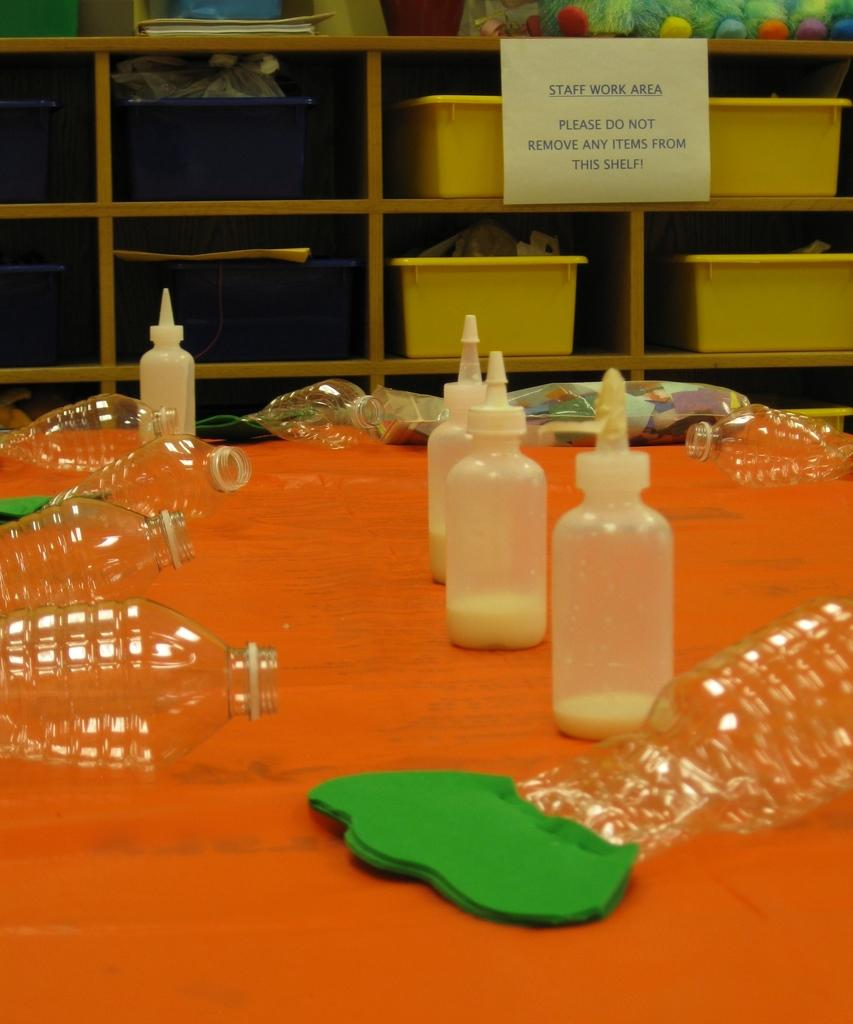What type of objects can be seen in the background of the image? There are containers in the background of the image. How are the containers arranged? The containers are in racks. What else is present in the image besides the containers? There is a paper note in the image. What can be seen in the containers? There are bottles with liquids in the image. Are there any empty bottles in the image? Yes, there are empty bottles on the table in the image. What type of nest can be seen in the image? There is no nest present in the image. What government policy is being discussed in the image? There is no discussion of government policy in the image. 